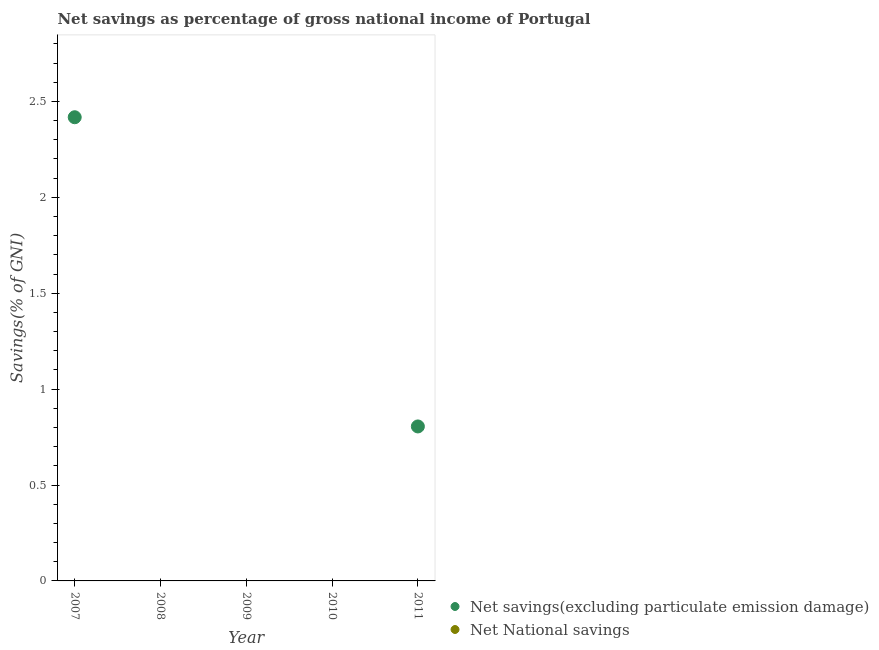Is the number of dotlines equal to the number of legend labels?
Offer a very short reply. No. Across all years, what is the maximum net savings(excluding particulate emission damage)?
Offer a very short reply. 2.42. In which year was the net savings(excluding particulate emission damage) maximum?
Ensure brevity in your answer.  2007. What is the total net national savings in the graph?
Your response must be concise. 0. What is the difference between the net savings(excluding particulate emission damage) in 2007 and that in 2011?
Offer a terse response. 1.61. What is the difference between the net savings(excluding particulate emission damage) in 2009 and the net national savings in 2008?
Offer a very short reply. 0. What is the average net savings(excluding particulate emission damage) per year?
Give a very brief answer. 0.64. In how many years, is the net savings(excluding particulate emission damage) greater than 2.7 %?
Your response must be concise. 0. What is the difference between the highest and the lowest net savings(excluding particulate emission damage)?
Your response must be concise. 2.42. Does the net savings(excluding particulate emission damage) monotonically increase over the years?
Make the answer very short. No. Is the net savings(excluding particulate emission damage) strictly greater than the net national savings over the years?
Make the answer very short. Yes. What is the difference between two consecutive major ticks on the Y-axis?
Make the answer very short. 0.5. Are the values on the major ticks of Y-axis written in scientific E-notation?
Your answer should be compact. No. How many legend labels are there?
Your response must be concise. 2. What is the title of the graph?
Provide a short and direct response. Net savings as percentage of gross national income of Portugal. Does "National Tourists" appear as one of the legend labels in the graph?
Offer a terse response. No. What is the label or title of the Y-axis?
Offer a terse response. Savings(% of GNI). What is the Savings(% of GNI) in Net savings(excluding particulate emission damage) in 2007?
Provide a succinct answer. 2.42. What is the Savings(% of GNI) of Net National savings in 2007?
Keep it short and to the point. 0. What is the Savings(% of GNI) of Net National savings in 2008?
Your answer should be compact. 0. What is the Savings(% of GNI) of Net savings(excluding particulate emission damage) in 2010?
Your answer should be compact. 0. What is the Savings(% of GNI) in Net savings(excluding particulate emission damage) in 2011?
Ensure brevity in your answer.  0.81. What is the Savings(% of GNI) of Net National savings in 2011?
Your response must be concise. 0. Across all years, what is the maximum Savings(% of GNI) of Net savings(excluding particulate emission damage)?
Your answer should be very brief. 2.42. What is the total Savings(% of GNI) in Net savings(excluding particulate emission damage) in the graph?
Make the answer very short. 3.22. What is the difference between the Savings(% of GNI) of Net savings(excluding particulate emission damage) in 2007 and that in 2011?
Provide a short and direct response. 1.61. What is the average Savings(% of GNI) in Net savings(excluding particulate emission damage) per year?
Ensure brevity in your answer.  0.64. What is the average Savings(% of GNI) of Net National savings per year?
Offer a very short reply. 0. What is the ratio of the Savings(% of GNI) in Net savings(excluding particulate emission damage) in 2007 to that in 2011?
Ensure brevity in your answer.  3. What is the difference between the highest and the lowest Savings(% of GNI) in Net savings(excluding particulate emission damage)?
Make the answer very short. 2.42. 